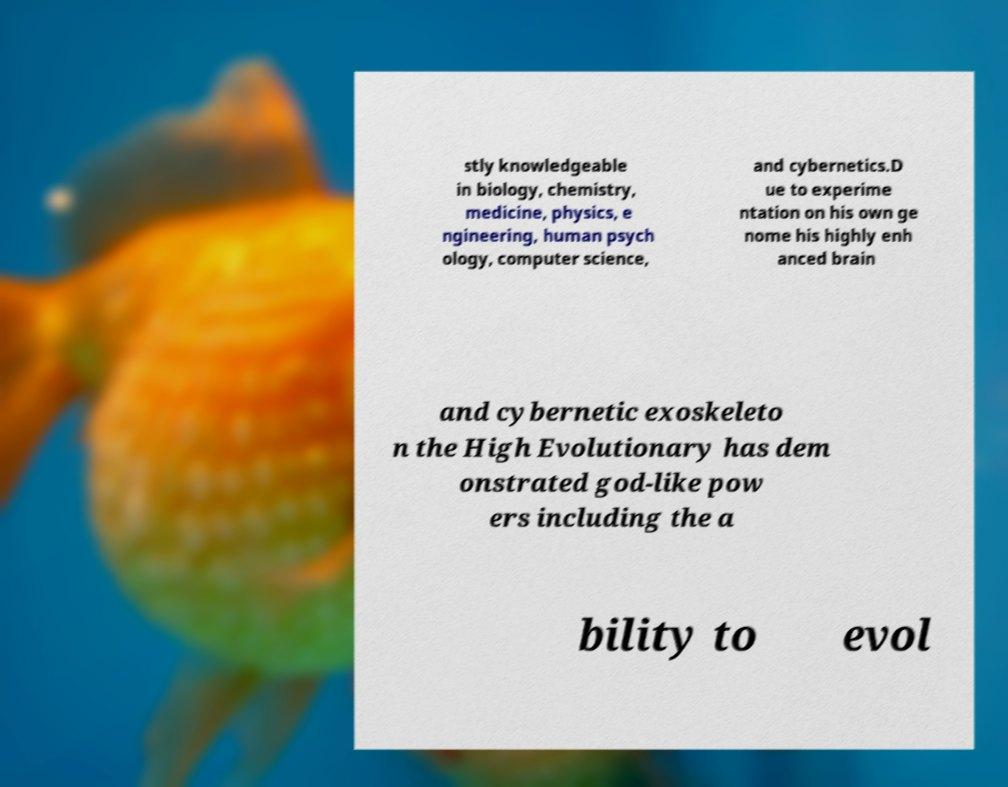There's text embedded in this image that I need extracted. Can you transcribe it verbatim? stly knowledgeable in biology, chemistry, medicine, physics, e ngineering, human psych ology, computer science, and cybernetics.D ue to experime ntation on his own ge nome his highly enh anced brain and cybernetic exoskeleto n the High Evolutionary has dem onstrated god-like pow ers including the a bility to evol 